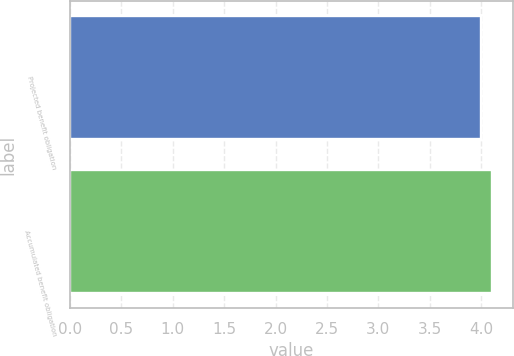Convert chart to OTSL. <chart><loc_0><loc_0><loc_500><loc_500><bar_chart><fcel>Projected benefit obligation<fcel>Accumulated benefit obligation<nl><fcel>4<fcel>4.1<nl></chart> 